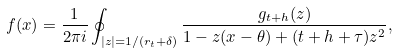Convert formula to latex. <formula><loc_0><loc_0><loc_500><loc_500>f ( x ) = \frac { 1 } { 2 \pi i } \oint _ { | z | = 1 / ( r _ { t } + \delta ) } \frac { g _ { t + h } ( z ) } { 1 - z ( x - \theta ) + ( t + h + \tau ) z ^ { 2 } } ,</formula> 